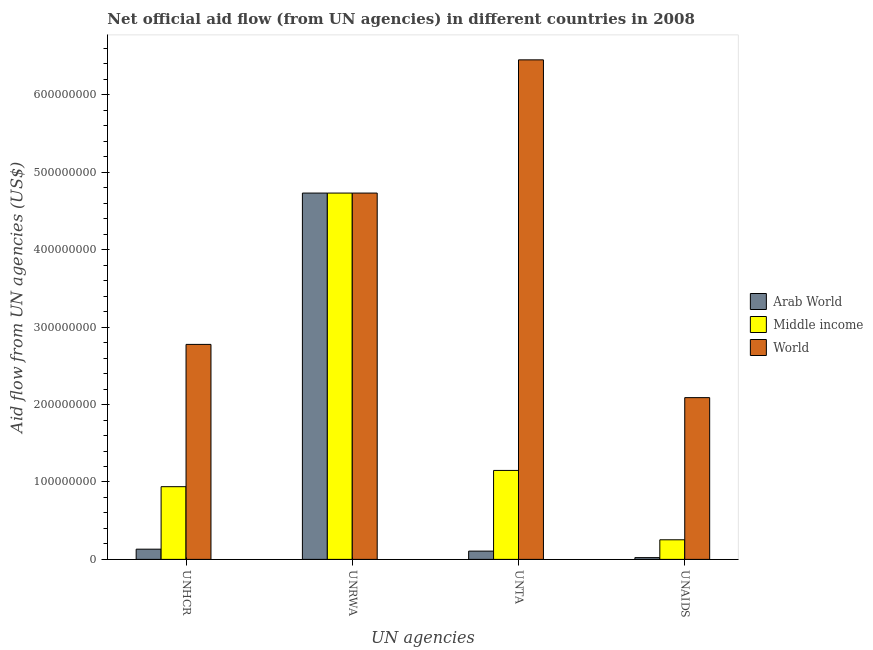How many groups of bars are there?
Keep it short and to the point. 4. Are the number of bars on each tick of the X-axis equal?
Give a very brief answer. Yes. What is the label of the 3rd group of bars from the left?
Keep it short and to the point. UNTA. What is the amount of aid given by unaids in Middle income?
Your answer should be very brief. 2.53e+07. Across all countries, what is the maximum amount of aid given by unhcr?
Ensure brevity in your answer.  2.78e+08. Across all countries, what is the minimum amount of aid given by unaids?
Keep it short and to the point. 2.28e+06. In which country was the amount of aid given by unaids maximum?
Provide a succinct answer. World. In which country was the amount of aid given by unta minimum?
Your answer should be compact. Arab World. What is the total amount of aid given by unrwa in the graph?
Provide a succinct answer. 1.42e+09. What is the difference between the amount of aid given by unrwa in World and that in Middle income?
Offer a very short reply. 0. What is the difference between the amount of aid given by unta in Middle income and the amount of aid given by unaids in World?
Ensure brevity in your answer.  -9.40e+07. What is the average amount of aid given by unaids per country?
Offer a very short reply. 7.88e+07. What is the difference between the amount of aid given by unrwa and amount of aid given by unta in Arab World?
Your response must be concise. 4.63e+08. What is the ratio of the amount of aid given by unrwa in Arab World to that in World?
Keep it short and to the point. 1. Is the amount of aid given by unta in Arab World less than that in Middle income?
Keep it short and to the point. Yes. What is the difference between the highest and the second highest amount of aid given by unta?
Your answer should be compact. 5.30e+08. What is the difference between the highest and the lowest amount of aid given by unaids?
Give a very brief answer. 2.07e+08. Is it the case that in every country, the sum of the amount of aid given by unaids and amount of aid given by unta is greater than the sum of amount of aid given by unhcr and amount of aid given by unrwa?
Your response must be concise. No. What does the 1st bar from the left in UNHCR represents?
Your response must be concise. Arab World. Are all the bars in the graph horizontal?
Make the answer very short. No. Are the values on the major ticks of Y-axis written in scientific E-notation?
Offer a terse response. No. Does the graph contain grids?
Keep it short and to the point. No. What is the title of the graph?
Offer a very short reply. Net official aid flow (from UN agencies) in different countries in 2008. Does "Peru" appear as one of the legend labels in the graph?
Provide a succinct answer. No. What is the label or title of the X-axis?
Make the answer very short. UN agencies. What is the label or title of the Y-axis?
Your response must be concise. Aid flow from UN agencies (US$). What is the Aid flow from UN agencies (US$) in Arab World in UNHCR?
Your answer should be very brief. 1.32e+07. What is the Aid flow from UN agencies (US$) in Middle income in UNHCR?
Keep it short and to the point. 9.39e+07. What is the Aid flow from UN agencies (US$) in World in UNHCR?
Offer a very short reply. 2.78e+08. What is the Aid flow from UN agencies (US$) in Arab World in UNRWA?
Offer a terse response. 4.73e+08. What is the Aid flow from UN agencies (US$) in Middle income in UNRWA?
Your response must be concise. 4.73e+08. What is the Aid flow from UN agencies (US$) in World in UNRWA?
Offer a terse response. 4.73e+08. What is the Aid flow from UN agencies (US$) of Arab World in UNTA?
Give a very brief answer. 1.07e+07. What is the Aid flow from UN agencies (US$) of Middle income in UNTA?
Offer a terse response. 1.15e+08. What is the Aid flow from UN agencies (US$) of World in UNTA?
Provide a succinct answer. 6.45e+08. What is the Aid flow from UN agencies (US$) in Arab World in UNAIDS?
Your answer should be very brief. 2.28e+06. What is the Aid flow from UN agencies (US$) in Middle income in UNAIDS?
Provide a succinct answer. 2.53e+07. What is the Aid flow from UN agencies (US$) of World in UNAIDS?
Your answer should be very brief. 2.09e+08. Across all UN agencies, what is the maximum Aid flow from UN agencies (US$) of Arab World?
Keep it short and to the point. 4.73e+08. Across all UN agencies, what is the maximum Aid flow from UN agencies (US$) in Middle income?
Ensure brevity in your answer.  4.73e+08. Across all UN agencies, what is the maximum Aid flow from UN agencies (US$) in World?
Ensure brevity in your answer.  6.45e+08. Across all UN agencies, what is the minimum Aid flow from UN agencies (US$) in Arab World?
Keep it short and to the point. 2.28e+06. Across all UN agencies, what is the minimum Aid flow from UN agencies (US$) in Middle income?
Your answer should be very brief. 2.53e+07. Across all UN agencies, what is the minimum Aid flow from UN agencies (US$) of World?
Your response must be concise. 2.09e+08. What is the total Aid flow from UN agencies (US$) in Arab World in the graph?
Your answer should be compact. 4.99e+08. What is the total Aid flow from UN agencies (US$) of Middle income in the graph?
Ensure brevity in your answer.  7.07e+08. What is the total Aid flow from UN agencies (US$) in World in the graph?
Make the answer very short. 1.61e+09. What is the difference between the Aid flow from UN agencies (US$) of Arab World in UNHCR and that in UNRWA?
Provide a short and direct response. -4.60e+08. What is the difference between the Aid flow from UN agencies (US$) of Middle income in UNHCR and that in UNRWA?
Offer a terse response. -3.79e+08. What is the difference between the Aid flow from UN agencies (US$) in World in UNHCR and that in UNRWA?
Keep it short and to the point. -1.95e+08. What is the difference between the Aid flow from UN agencies (US$) in Arab World in UNHCR and that in UNTA?
Your response must be concise. 2.50e+06. What is the difference between the Aid flow from UN agencies (US$) in Middle income in UNHCR and that in UNTA?
Make the answer very short. -2.10e+07. What is the difference between the Aid flow from UN agencies (US$) in World in UNHCR and that in UNTA?
Your response must be concise. -3.68e+08. What is the difference between the Aid flow from UN agencies (US$) of Arab World in UNHCR and that in UNAIDS?
Ensure brevity in your answer.  1.09e+07. What is the difference between the Aid flow from UN agencies (US$) in Middle income in UNHCR and that in UNAIDS?
Ensure brevity in your answer.  6.86e+07. What is the difference between the Aid flow from UN agencies (US$) in World in UNHCR and that in UNAIDS?
Your response must be concise. 6.88e+07. What is the difference between the Aid flow from UN agencies (US$) of Arab World in UNRWA and that in UNTA?
Give a very brief answer. 4.63e+08. What is the difference between the Aid flow from UN agencies (US$) in Middle income in UNRWA and that in UNTA?
Offer a terse response. 3.58e+08. What is the difference between the Aid flow from UN agencies (US$) of World in UNRWA and that in UNTA?
Provide a succinct answer. -1.72e+08. What is the difference between the Aid flow from UN agencies (US$) in Arab World in UNRWA and that in UNAIDS?
Provide a short and direct response. 4.71e+08. What is the difference between the Aid flow from UN agencies (US$) of Middle income in UNRWA and that in UNAIDS?
Offer a very short reply. 4.48e+08. What is the difference between the Aid flow from UN agencies (US$) in World in UNRWA and that in UNAIDS?
Ensure brevity in your answer.  2.64e+08. What is the difference between the Aid flow from UN agencies (US$) of Arab World in UNTA and that in UNAIDS?
Ensure brevity in your answer.  8.40e+06. What is the difference between the Aid flow from UN agencies (US$) in Middle income in UNTA and that in UNAIDS?
Offer a terse response. 8.96e+07. What is the difference between the Aid flow from UN agencies (US$) in World in UNTA and that in UNAIDS?
Offer a terse response. 4.36e+08. What is the difference between the Aid flow from UN agencies (US$) of Arab World in UNHCR and the Aid flow from UN agencies (US$) of Middle income in UNRWA?
Offer a terse response. -4.60e+08. What is the difference between the Aid flow from UN agencies (US$) in Arab World in UNHCR and the Aid flow from UN agencies (US$) in World in UNRWA?
Your response must be concise. -4.60e+08. What is the difference between the Aid flow from UN agencies (US$) in Middle income in UNHCR and the Aid flow from UN agencies (US$) in World in UNRWA?
Ensure brevity in your answer.  -3.79e+08. What is the difference between the Aid flow from UN agencies (US$) of Arab World in UNHCR and the Aid flow from UN agencies (US$) of Middle income in UNTA?
Make the answer very short. -1.02e+08. What is the difference between the Aid flow from UN agencies (US$) of Arab World in UNHCR and the Aid flow from UN agencies (US$) of World in UNTA?
Provide a succinct answer. -6.32e+08. What is the difference between the Aid flow from UN agencies (US$) of Middle income in UNHCR and the Aid flow from UN agencies (US$) of World in UNTA?
Ensure brevity in your answer.  -5.51e+08. What is the difference between the Aid flow from UN agencies (US$) of Arab World in UNHCR and the Aid flow from UN agencies (US$) of Middle income in UNAIDS?
Your response must be concise. -1.21e+07. What is the difference between the Aid flow from UN agencies (US$) in Arab World in UNHCR and the Aid flow from UN agencies (US$) in World in UNAIDS?
Offer a very short reply. -1.96e+08. What is the difference between the Aid flow from UN agencies (US$) of Middle income in UNHCR and the Aid flow from UN agencies (US$) of World in UNAIDS?
Your answer should be very brief. -1.15e+08. What is the difference between the Aid flow from UN agencies (US$) in Arab World in UNRWA and the Aid flow from UN agencies (US$) in Middle income in UNTA?
Offer a terse response. 3.58e+08. What is the difference between the Aid flow from UN agencies (US$) in Arab World in UNRWA and the Aid flow from UN agencies (US$) in World in UNTA?
Make the answer very short. -1.72e+08. What is the difference between the Aid flow from UN agencies (US$) in Middle income in UNRWA and the Aid flow from UN agencies (US$) in World in UNTA?
Keep it short and to the point. -1.72e+08. What is the difference between the Aid flow from UN agencies (US$) of Arab World in UNRWA and the Aid flow from UN agencies (US$) of Middle income in UNAIDS?
Ensure brevity in your answer.  4.48e+08. What is the difference between the Aid flow from UN agencies (US$) of Arab World in UNRWA and the Aid flow from UN agencies (US$) of World in UNAIDS?
Your answer should be compact. 2.64e+08. What is the difference between the Aid flow from UN agencies (US$) in Middle income in UNRWA and the Aid flow from UN agencies (US$) in World in UNAIDS?
Your answer should be compact. 2.64e+08. What is the difference between the Aid flow from UN agencies (US$) in Arab World in UNTA and the Aid flow from UN agencies (US$) in Middle income in UNAIDS?
Offer a terse response. -1.46e+07. What is the difference between the Aid flow from UN agencies (US$) in Arab World in UNTA and the Aid flow from UN agencies (US$) in World in UNAIDS?
Offer a terse response. -1.98e+08. What is the difference between the Aid flow from UN agencies (US$) of Middle income in UNTA and the Aid flow from UN agencies (US$) of World in UNAIDS?
Your answer should be compact. -9.40e+07. What is the average Aid flow from UN agencies (US$) in Arab World per UN agencies?
Give a very brief answer. 1.25e+08. What is the average Aid flow from UN agencies (US$) of Middle income per UN agencies?
Your answer should be very brief. 1.77e+08. What is the average Aid flow from UN agencies (US$) in World per UN agencies?
Provide a succinct answer. 4.01e+08. What is the difference between the Aid flow from UN agencies (US$) in Arab World and Aid flow from UN agencies (US$) in Middle income in UNHCR?
Provide a succinct answer. -8.07e+07. What is the difference between the Aid flow from UN agencies (US$) of Arab World and Aid flow from UN agencies (US$) of World in UNHCR?
Make the answer very short. -2.65e+08. What is the difference between the Aid flow from UN agencies (US$) in Middle income and Aid flow from UN agencies (US$) in World in UNHCR?
Your answer should be very brief. -1.84e+08. What is the difference between the Aid flow from UN agencies (US$) of Arab World and Aid flow from UN agencies (US$) of World in UNRWA?
Make the answer very short. 0. What is the difference between the Aid flow from UN agencies (US$) in Arab World and Aid flow from UN agencies (US$) in Middle income in UNTA?
Offer a terse response. -1.04e+08. What is the difference between the Aid flow from UN agencies (US$) in Arab World and Aid flow from UN agencies (US$) in World in UNTA?
Your answer should be compact. -6.35e+08. What is the difference between the Aid flow from UN agencies (US$) of Middle income and Aid flow from UN agencies (US$) of World in UNTA?
Offer a very short reply. -5.30e+08. What is the difference between the Aid flow from UN agencies (US$) of Arab World and Aid flow from UN agencies (US$) of Middle income in UNAIDS?
Keep it short and to the point. -2.30e+07. What is the difference between the Aid flow from UN agencies (US$) of Arab World and Aid flow from UN agencies (US$) of World in UNAIDS?
Provide a succinct answer. -2.07e+08. What is the difference between the Aid flow from UN agencies (US$) of Middle income and Aid flow from UN agencies (US$) of World in UNAIDS?
Provide a short and direct response. -1.84e+08. What is the ratio of the Aid flow from UN agencies (US$) in Arab World in UNHCR to that in UNRWA?
Your answer should be compact. 0.03. What is the ratio of the Aid flow from UN agencies (US$) in Middle income in UNHCR to that in UNRWA?
Offer a very short reply. 0.2. What is the ratio of the Aid flow from UN agencies (US$) of World in UNHCR to that in UNRWA?
Your response must be concise. 0.59. What is the ratio of the Aid flow from UN agencies (US$) in Arab World in UNHCR to that in UNTA?
Your answer should be very brief. 1.23. What is the ratio of the Aid flow from UN agencies (US$) in Middle income in UNHCR to that in UNTA?
Your answer should be very brief. 0.82. What is the ratio of the Aid flow from UN agencies (US$) of World in UNHCR to that in UNTA?
Give a very brief answer. 0.43. What is the ratio of the Aid flow from UN agencies (US$) in Arab World in UNHCR to that in UNAIDS?
Provide a short and direct response. 5.78. What is the ratio of the Aid flow from UN agencies (US$) in Middle income in UNHCR to that in UNAIDS?
Give a very brief answer. 3.71. What is the ratio of the Aid flow from UN agencies (US$) in World in UNHCR to that in UNAIDS?
Give a very brief answer. 1.33. What is the ratio of the Aid flow from UN agencies (US$) in Arab World in UNRWA to that in UNTA?
Your answer should be very brief. 44.31. What is the ratio of the Aid flow from UN agencies (US$) in Middle income in UNRWA to that in UNTA?
Your answer should be compact. 4.12. What is the ratio of the Aid flow from UN agencies (US$) of World in UNRWA to that in UNTA?
Make the answer very short. 0.73. What is the ratio of the Aid flow from UN agencies (US$) in Arab World in UNRWA to that in UNAIDS?
Provide a short and direct response. 207.54. What is the ratio of the Aid flow from UN agencies (US$) of Middle income in UNRWA to that in UNAIDS?
Keep it short and to the point. 18.69. What is the ratio of the Aid flow from UN agencies (US$) in World in UNRWA to that in UNAIDS?
Offer a terse response. 2.26. What is the ratio of the Aid flow from UN agencies (US$) of Arab World in UNTA to that in UNAIDS?
Keep it short and to the point. 4.68. What is the ratio of the Aid flow from UN agencies (US$) of Middle income in UNTA to that in UNAIDS?
Your answer should be compact. 4.54. What is the ratio of the Aid flow from UN agencies (US$) of World in UNTA to that in UNAIDS?
Provide a succinct answer. 3.09. What is the difference between the highest and the second highest Aid flow from UN agencies (US$) in Arab World?
Ensure brevity in your answer.  4.60e+08. What is the difference between the highest and the second highest Aid flow from UN agencies (US$) in Middle income?
Ensure brevity in your answer.  3.58e+08. What is the difference between the highest and the second highest Aid flow from UN agencies (US$) of World?
Your answer should be very brief. 1.72e+08. What is the difference between the highest and the lowest Aid flow from UN agencies (US$) of Arab World?
Your answer should be compact. 4.71e+08. What is the difference between the highest and the lowest Aid flow from UN agencies (US$) of Middle income?
Offer a very short reply. 4.48e+08. What is the difference between the highest and the lowest Aid flow from UN agencies (US$) of World?
Provide a short and direct response. 4.36e+08. 